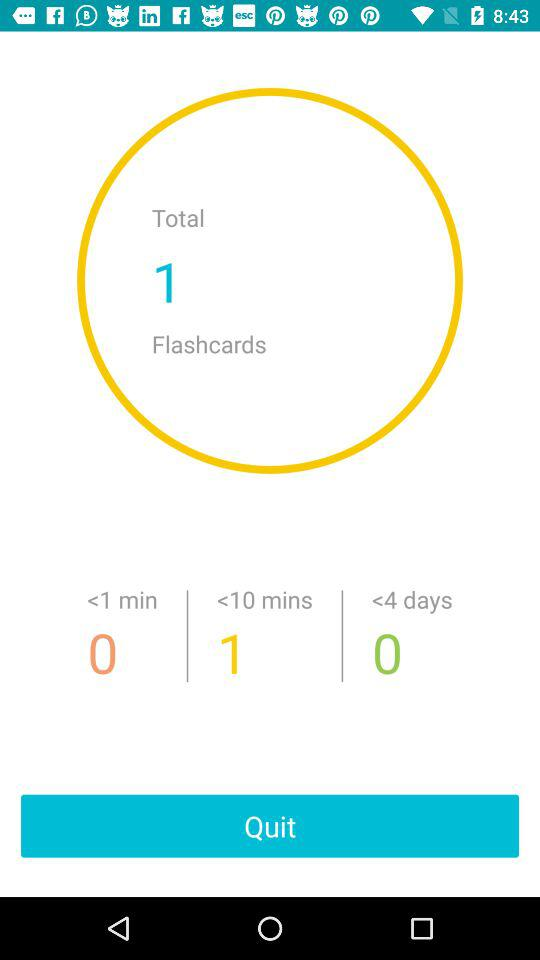What duration is given for one flashcard? The duration given for one flashcard is less than 10 minutes. 